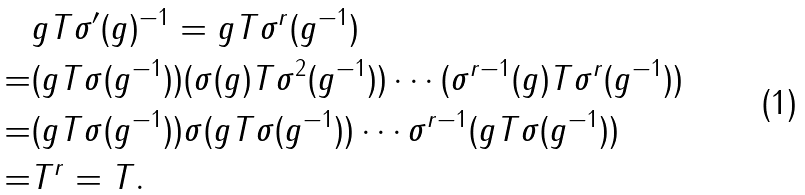Convert formula to latex. <formula><loc_0><loc_0><loc_500><loc_500>& g T \sigma ^ { \prime } ( g ) ^ { - 1 } = g T \sigma ^ { r } ( g ^ { - 1 } ) \\ = & ( g T \sigma ( g ^ { - 1 } ) ) ( \sigma ( g ) T \sigma ^ { 2 } ( g ^ { - 1 } ) ) \cdots ( \sigma ^ { r - 1 } ( g ) T \sigma ^ { r } ( g ^ { - 1 } ) ) \\ = & ( g T \sigma ( g ^ { - 1 } ) ) \sigma ( g T \sigma ( g ^ { - 1 } ) ) \cdots \sigma ^ { r - 1 } ( g T \sigma ( g ^ { - 1 } ) ) \\ = & T ^ { r } = T .</formula> 